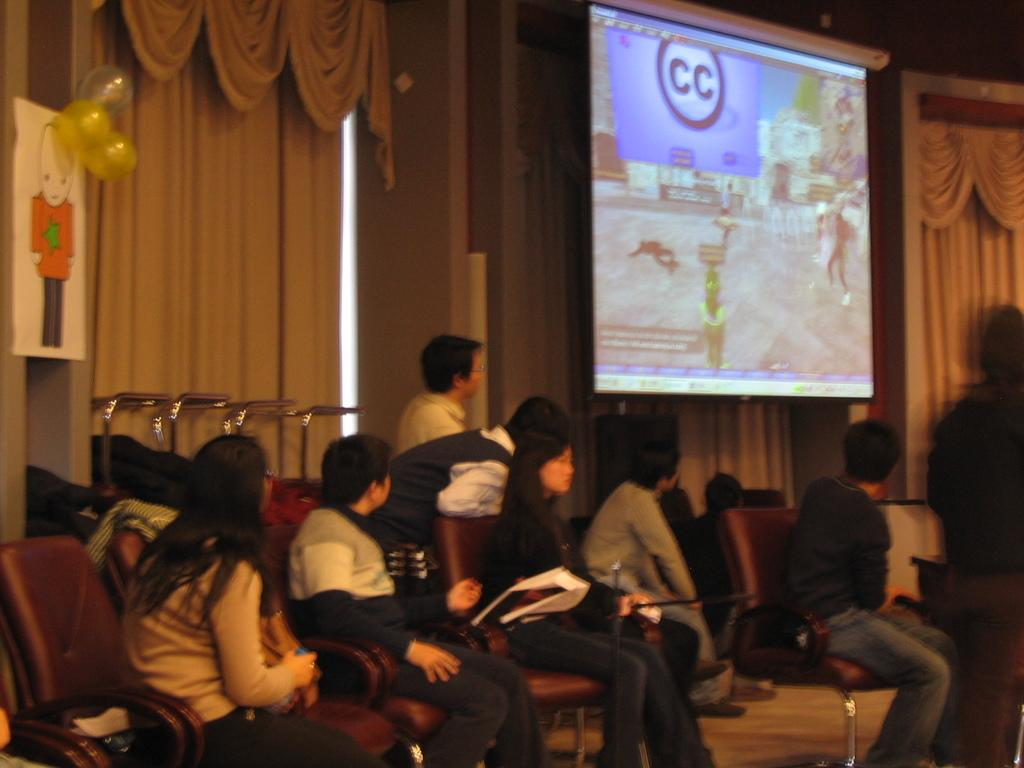What are the people in the image doing? The people in the image are sitting on chairs and watching a screen. Can you describe the setting in which the people are sitting? There is a curtain in the image, which suggests that the people are in a room or an enclosed space. How many trays of food are being served to the giants in the image? There are no giants or trays of food present in the image. What type of waste can be seen in the image? There is no waste visible in the image; it features people sitting on chairs and watching a screen. 